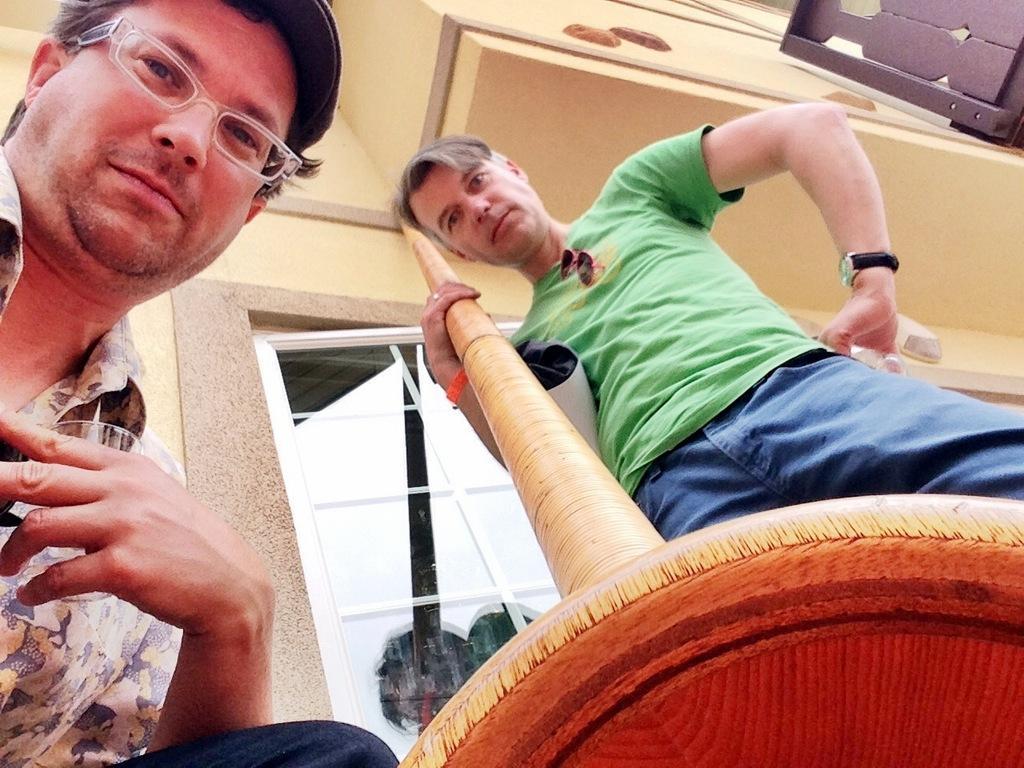Could you give a brief overview of what you see in this image? In this image we can see two men. One person is holding a glass and another person is holding a wooden pole. In the background we can see a window and a building. 